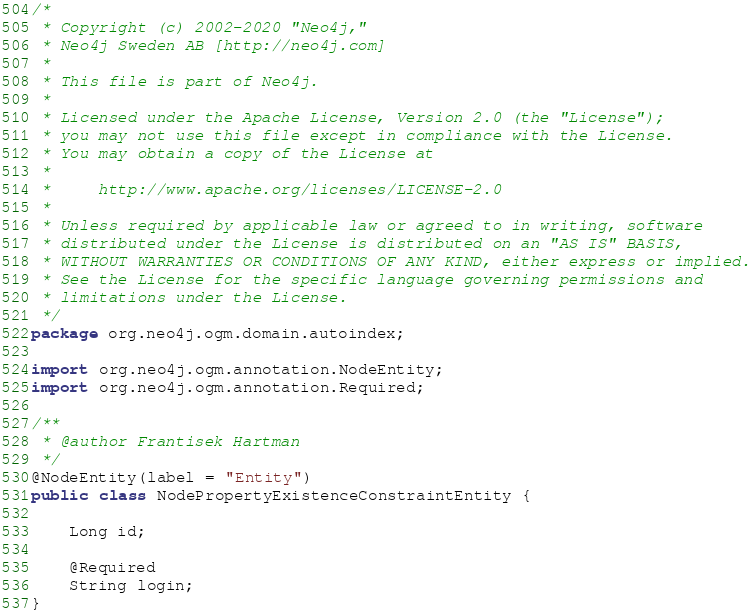<code> <loc_0><loc_0><loc_500><loc_500><_Java_>/*
 * Copyright (c) 2002-2020 "Neo4j,"
 * Neo4j Sweden AB [http://neo4j.com]
 *
 * This file is part of Neo4j.
 *
 * Licensed under the Apache License, Version 2.0 (the "License");
 * you may not use this file except in compliance with the License.
 * You may obtain a copy of the License at
 *
 *     http://www.apache.org/licenses/LICENSE-2.0
 *
 * Unless required by applicable law or agreed to in writing, software
 * distributed under the License is distributed on an "AS IS" BASIS,
 * WITHOUT WARRANTIES OR CONDITIONS OF ANY KIND, either express or implied.
 * See the License for the specific language governing permissions and
 * limitations under the License.
 */
package org.neo4j.ogm.domain.autoindex;

import org.neo4j.ogm.annotation.NodeEntity;
import org.neo4j.ogm.annotation.Required;

/**
 * @author Frantisek Hartman
 */
@NodeEntity(label = "Entity")
public class NodePropertyExistenceConstraintEntity {

    Long id;

    @Required
    String login;
}
</code> 